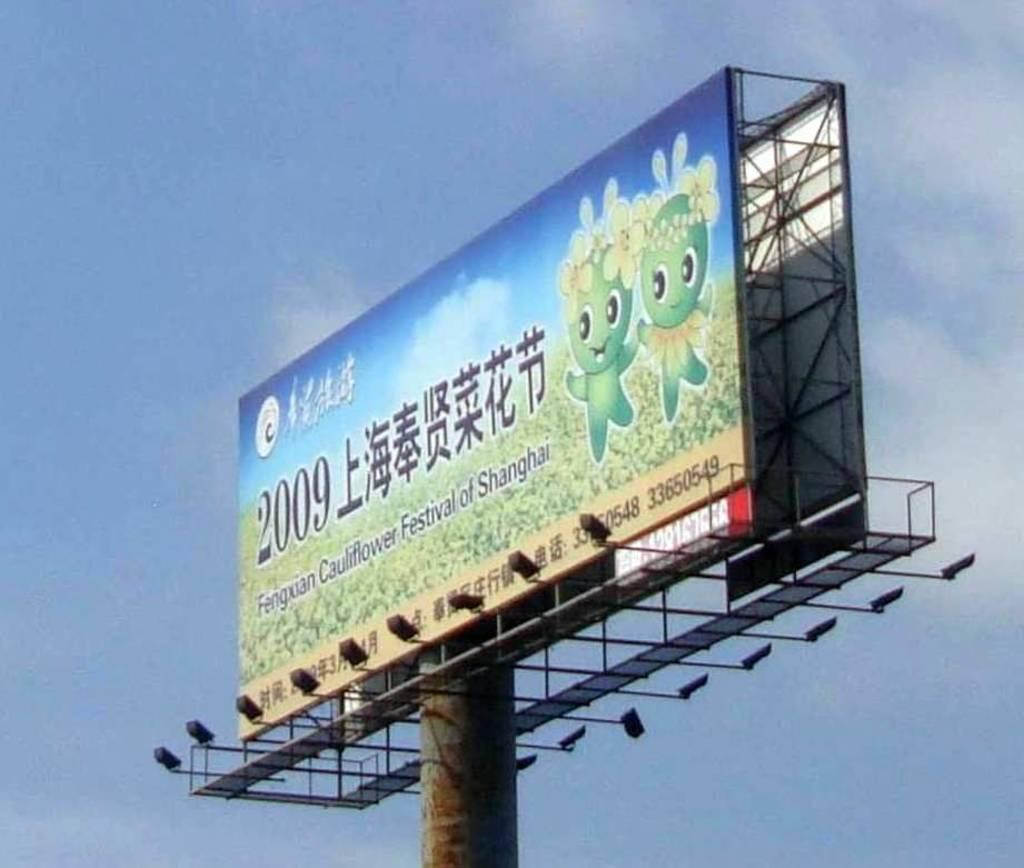<image>
Give a short and clear explanation of the subsequent image. A billboard with cartoon green creatures has the year 2009 on it. 